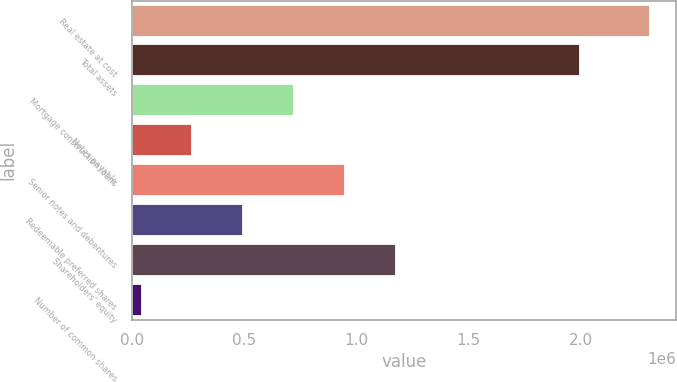<chart> <loc_0><loc_0><loc_500><loc_500><bar_chart><fcel>Real estate at cost<fcel>Total assets<fcel>Mortgage construction loans<fcel>Notes payable<fcel>Senior notes and debentures<fcel>Redeemable preferred shares<fcel>Shareholders' equity<fcel>Number of common shares<nl><fcel>2.30683e+06<fcel>1.99666e+06<fcel>722522<fcel>269864<fcel>948851<fcel>496193<fcel>1.17518e+06<fcel>43535<nl></chart> 